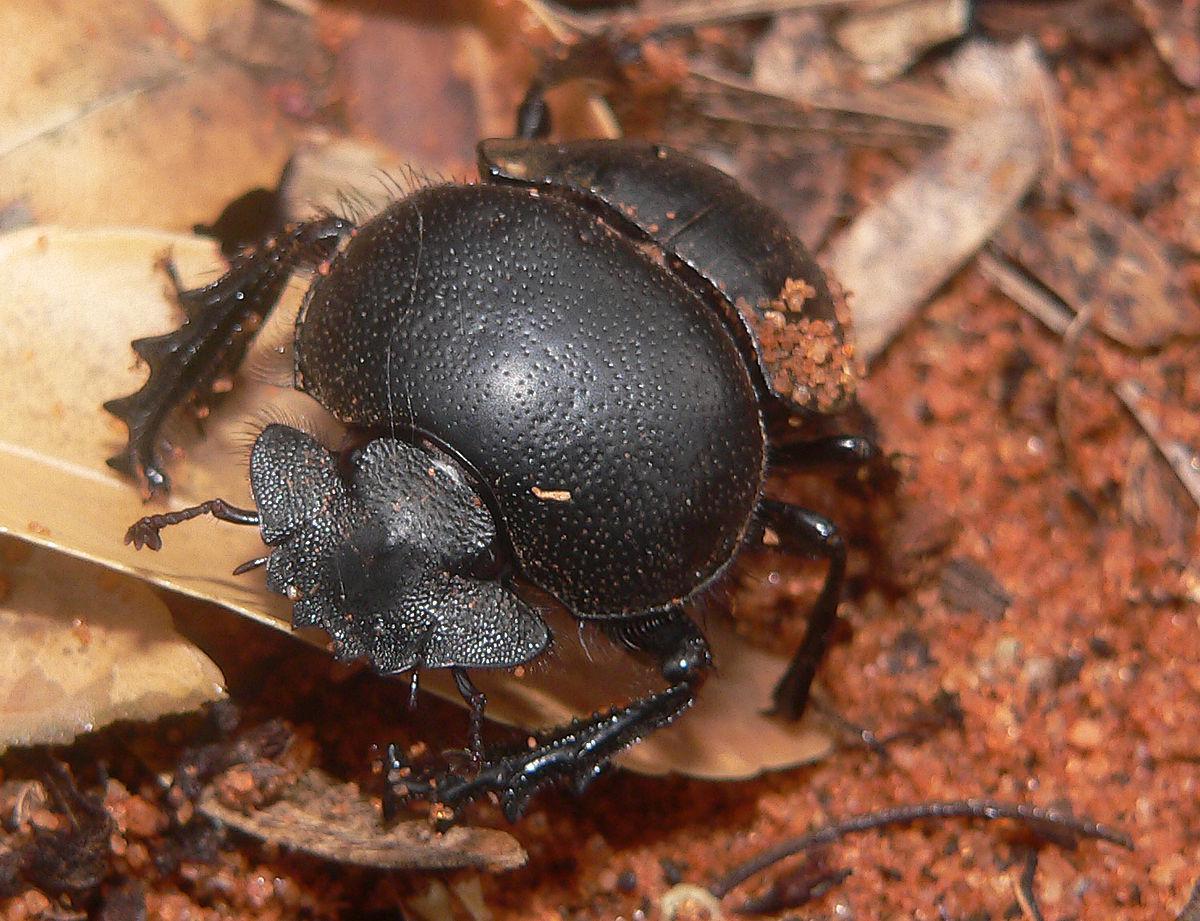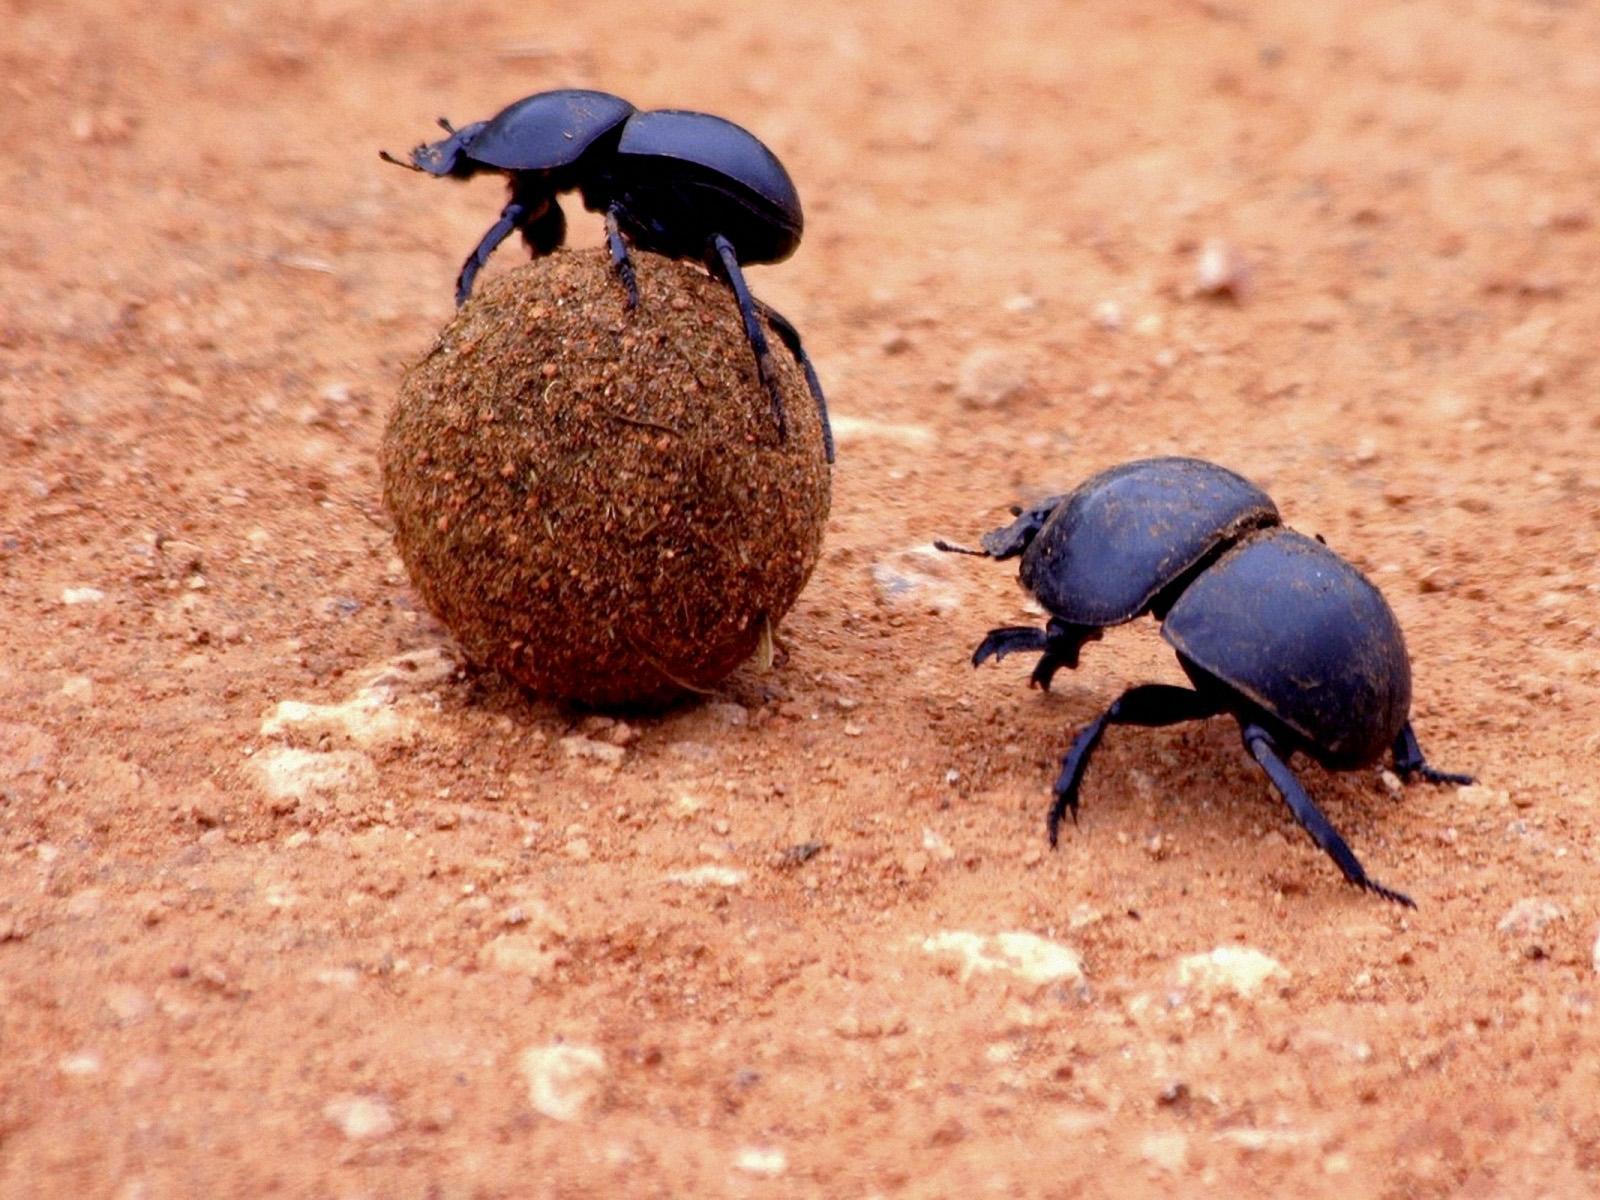The first image is the image on the left, the second image is the image on the right. For the images shown, is this caption "There are two beetles touching a dungball." true? Answer yes or no. No. 